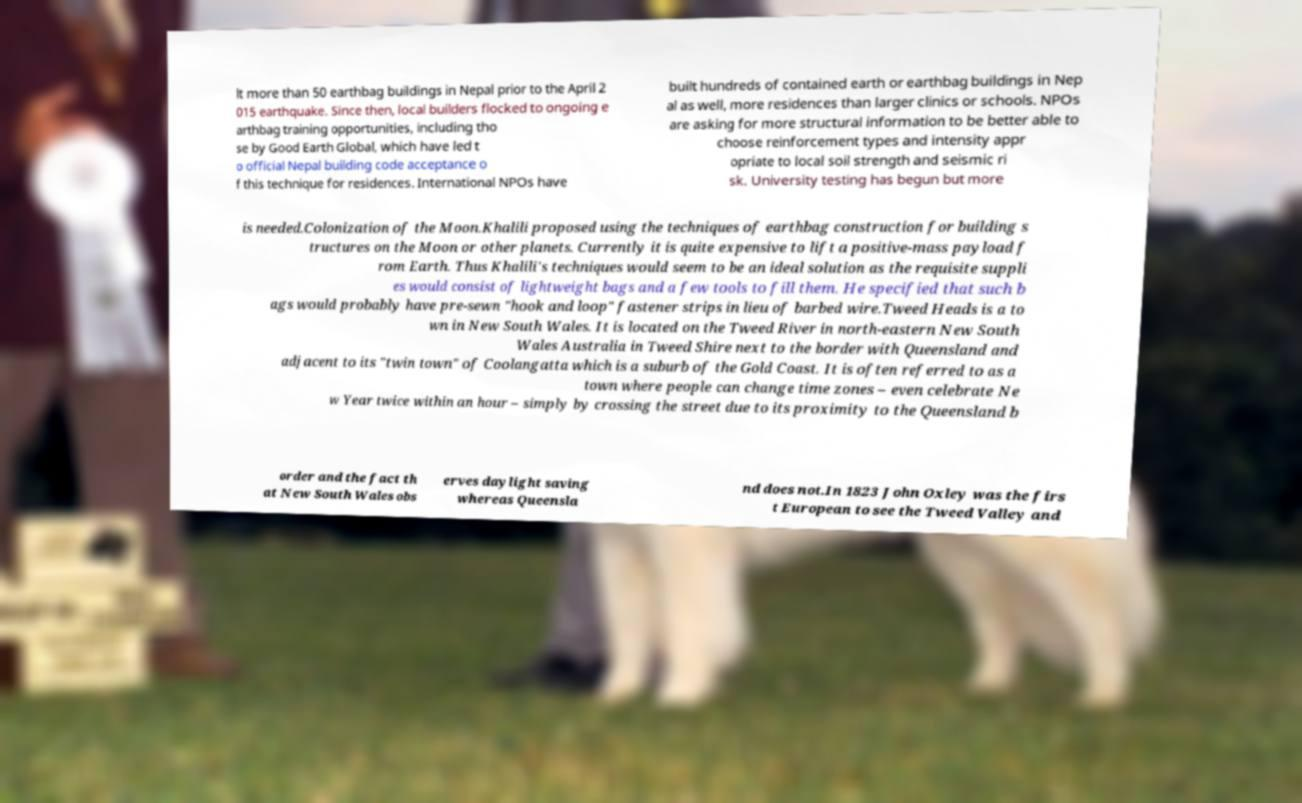Can you accurately transcribe the text from the provided image for me? lt more than 50 earthbag buildings in Nepal prior to the April 2 015 earthquake. Since then, local builders flocked to ongoing e arthbag training opportunities, including tho se by Good Earth Global, which have led t o official Nepal building code acceptance o f this technique for residences. International NPOs have built hundreds of contained earth or earthbag buildings in Nep al as well, more residences than larger clinics or schools. NPOs are asking for more structural information to be better able to choose reinforcement types and intensity appr opriate to local soil strength and seismic ri sk. University testing has begun but more is needed.Colonization of the Moon.Khalili proposed using the techniques of earthbag construction for building s tructures on the Moon or other planets. Currently it is quite expensive to lift a positive-mass payload f rom Earth. Thus Khalili's techniques would seem to be an ideal solution as the requisite suppli es would consist of lightweight bags and a few tools to fill them. He specified that such b ags would probably have pre-sewn "hook and loop" fastener strips in lieu of barbed wire.Tweed Heads is a to wn in New South Wales. It is located on the Tweed River in north-eastern New South Wales Australia in Tweed Shire next to the border with Queensland and adjacent to its "twin town" of Coolangatta which is a suburb of the Gold Coast. It is often referred to as a town where people can change time zones – even celebrate Ne w Year twice within an hour – simply by crossing the street due to its proximity to the Queensland b order and the fact th at New South Wales obs erves daylight saving whereas Queensla nd does not.In 1823 John Oxley was the firs t European to see the Tweed Valley and 